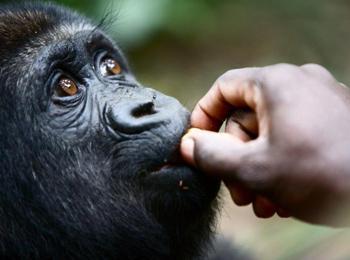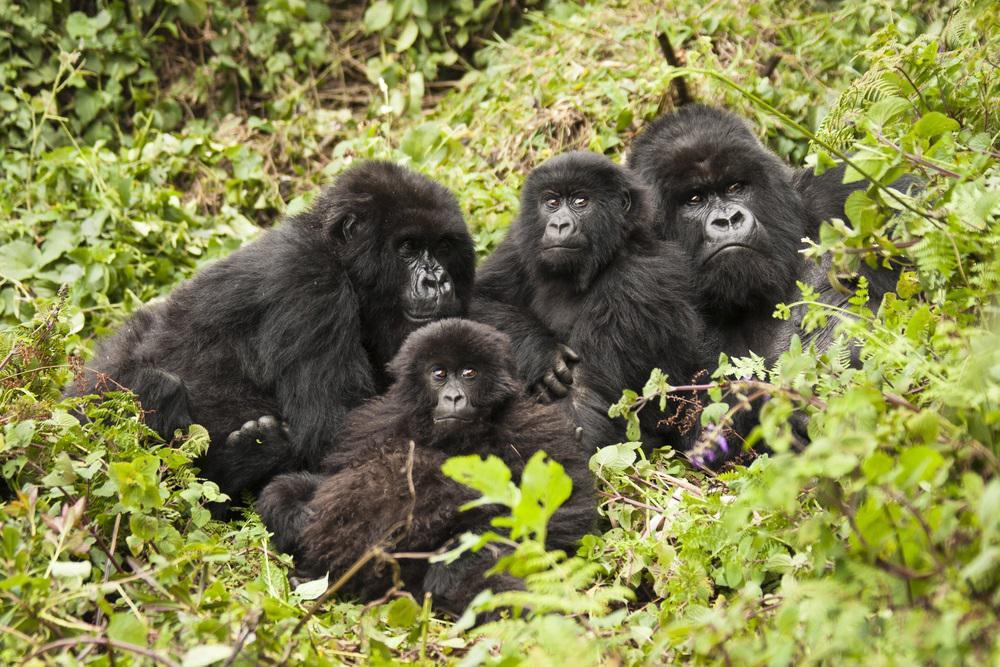The first image is the image on the left, the second image is the image on the right. For the images shown, is this caption "There are more animals in the image on the right." true? Answer yes or no. Yes. The first image is the image on the left, the second image is the image on the right. Evaluate the accuracy of this statement regarding the images: "The right image contains one gorilla, an adult male with its arms extended down to the ground in front of its body.". Is it true? Answer yes or no. No. 